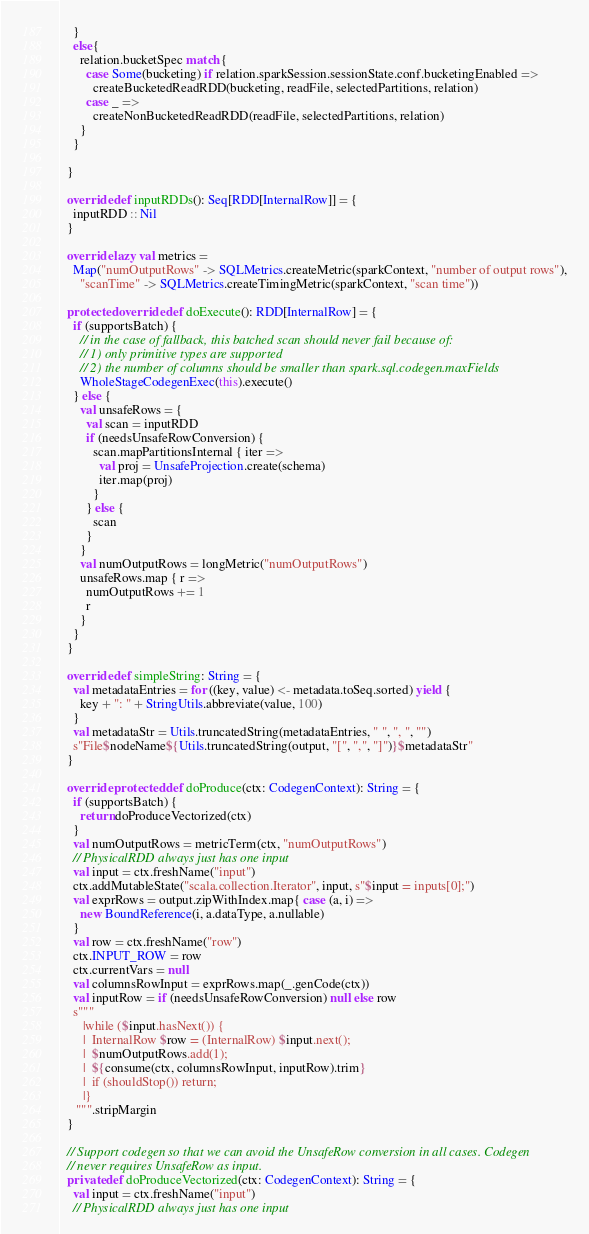<code> <loc_0><loc_0><loc_500><loc_500><_Scala_>    }
    else{
      relation.bucketSpec match {
        case Some(bucketing) if relation.sparkSession.sessionState.conf.bucketingEnabled =>
          createBucketedReadRDD(bucketing, readFile, selectedPartitions, relation)
        case _ =>
          createNonBucketedReadRDD(readFile, selectedPartitions, relation)
      }
    }

  }

  override def inputRDDs(): Seq[RDD[InternalRow]] = {
    inputRDD :: Nil
  }

  override lazy val metrics =
    Map("numOutputRows" -> SQLMetrics.createMetric(sparkContext, "number of output rows"),
      "scanTime" -> SQLMetrics.createTimingMetric(sparkContext, "scan time"))

  protected override def doExecute(): RDD[InternalRow] = {
    if (supportsBatch) {
      // in the case of fallback, this batched scan should never fail because of:
      // 1) only primitive types are supported
      // 2) the number of columns should be smaller than spark.sql.codegen.maxFields
      WholeStageCodegenExec(this).execute()
    } else {
      val unsafeRows = {
        val scan = inputRDD
        if (needsUnsafeRowConversion) {
          scan.mapPartitionsInternal { iter =>
            val proj = UnsafeProjection.create(schema)
            iter.map(proj)
          }
        } else {
          scan
        }
      }
      val numOutputRows = longMetric("numOutputRows")
      unsafeRows.map { r =>
        numOutputRows += 1
        r
      }
    }
  }

  override def simpleString: String = {
    val metadataEntries = for ((key, value) <- metadata.toSeq.sorted) yield {
      key + ": " + StringUtils.abbreviate(value, 100)
    }
    val metadataStr = Utils.truncatedString(metadataEntries, " ", ", ", "")
    s"File$nodeName${Utils.truncatedString(output, "[", ",", "]")}$metadataStr"
  }

  override protected def doProduce(ctx: CodegenContext): String = {
    if (supportsBatch) {
      return doProduceVectorized(ctx)
    }
    val numOutputRows = metricTerm(ctx, "numOutputRows")
    // PhysicalRDD always just has one input
    val input = ctx.freshName("input")
    ctx.addMutableState("scala.collection.Iterator", input, s"$input = inputs[0];")
    val exprRows = output.zipWithIndex.map{ case (a, i) =>
      new BoundReference(i, a.dataType, a.nullable)
    }
    val row = ctx.freshName("row")
    ctx.INPUT_ROW = row
    ctx.currentVars = null
    val columnsRowInput = exprRows.map(_.genCode(ctx))
    val inputRow = if (needsUnsafeRowConversion) null else row
    s"""
       |while ($input.hasNext()) {
       |  InternalRow $row = (InternalRow) $input.next();
       |  $numOutputRows.add(1);
       |  ${consume(ctx, columnsRowInput, inputRow).trim}
       |  if (shouldStop()) return;
       |}
     """.stripMargin
  }

  // Support codegen so that we can avoid the UnsafeRow conversion in all cases. Codegen
  // never requires UnsafeRow as input.
  private def doProduceVectorized(ctx: CodegenContext): String = {
    val input = ctx.freshName("input")
    // PhysicalRDD always just has one input</code> 